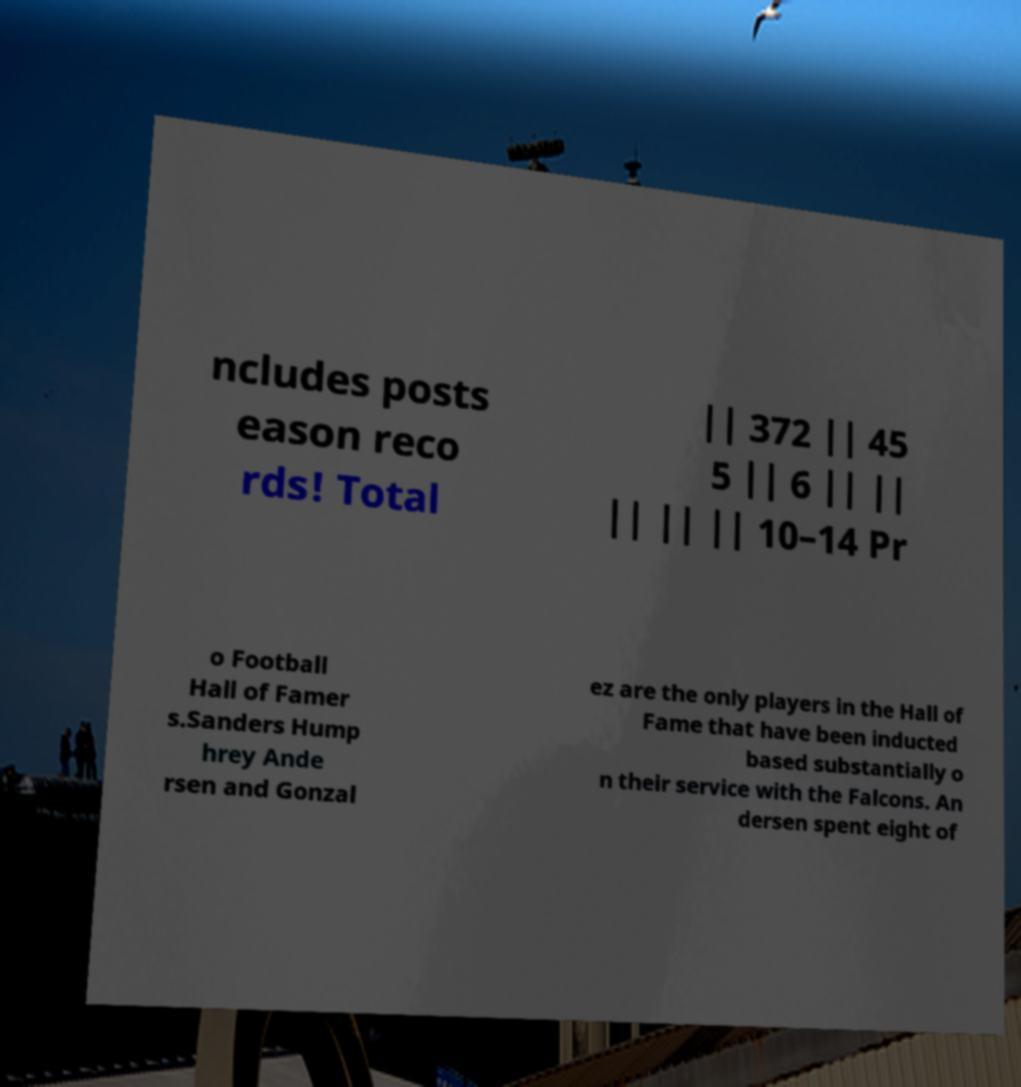I need the written content from this picture converted into text. Can you do that? ncludes posts eason reco rds! Total || 372 || 45 5 || 6 || || || || || 10–14 Pr o Football Hall of Famer s.Sanders Hump hrey Ande rsen and Gonzal ez are the only players in the Hall of Fame that have been inducted based substantially o n their service with the Falcons. An dersen spent eight of 